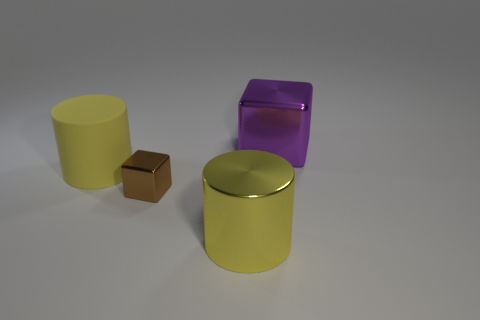What is the shape of the large metallic thing that is behind the metal block on the left side of the big purple thing?
Make the answer very short. Cube. Is there a big purple object that has the same shape as the brown shiny thing?
Keep it short and to the point. Yes. What number of brown blocks are there?
Your response must be concise. 1. Are the large cylinder that is behind the small metal cube and the tiny brown block made of the same material?
Your answer should be compact. No. Are there any other cylinders of the same size as the yellow rubber cylinder?
Your answer should be very brief. Yes. Do the purple shiny object and the yellow thing that is behind the yellow metallic thing have the same shape?
Offer a very short reply. No. Is there a large cylinder right of the block that is in front of the cube that is behind the large matte cylinder?
Keep it short and to the point. Yes. What size is the brown metallic thing?
Offer a very short reply. Small. How many other objects are the same color as the tiny metal cube?
Provide a succinct answer. 0. There is a big shiny object that is in front of the purple cube; does it have the same shape as the yellow matte object?
Ensure brevity in your answer.  Yes. 